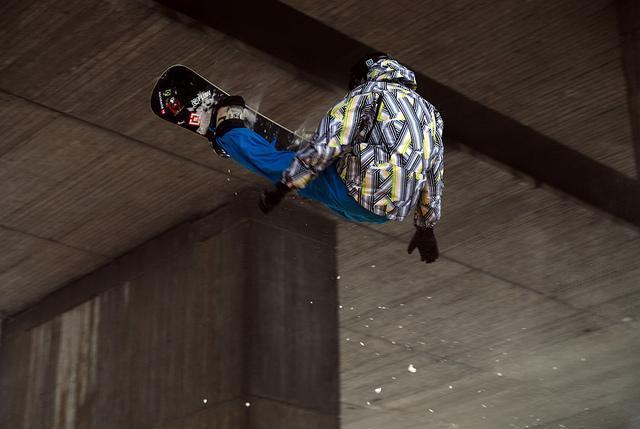How many snowboards are there?
Give a very brief answer. 1. 